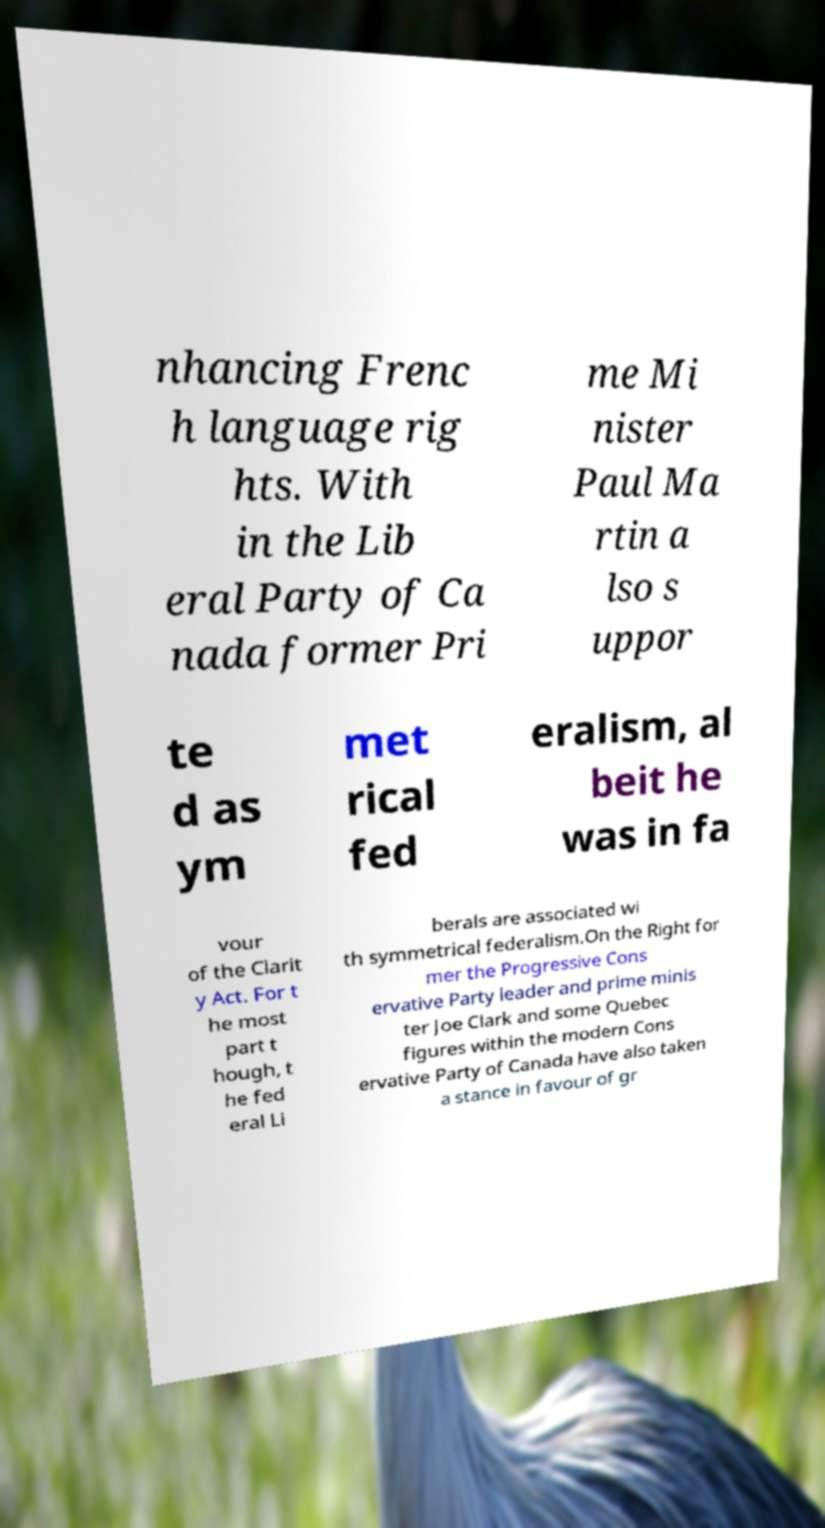Could you extract and type out the text from this image? nhancing Frenc h language rig hts. With in the Lib eral Party of Ca nada former Pri me Mi nister Paul Ma rtin a lso s uppor te d as ym met rical fed eralism, al beit he was in fa vour of the Clarit y Act. For t he most part t hough, t he fed eral Li berals are associated wi th symmetrical federalism.On the Right for mer the Progressive Cons ervative Party leader and prime minis ter Joe Clark and some Quebec figures within the modern Cons ervative Party of Canada have also taken a stance in favour of gr 